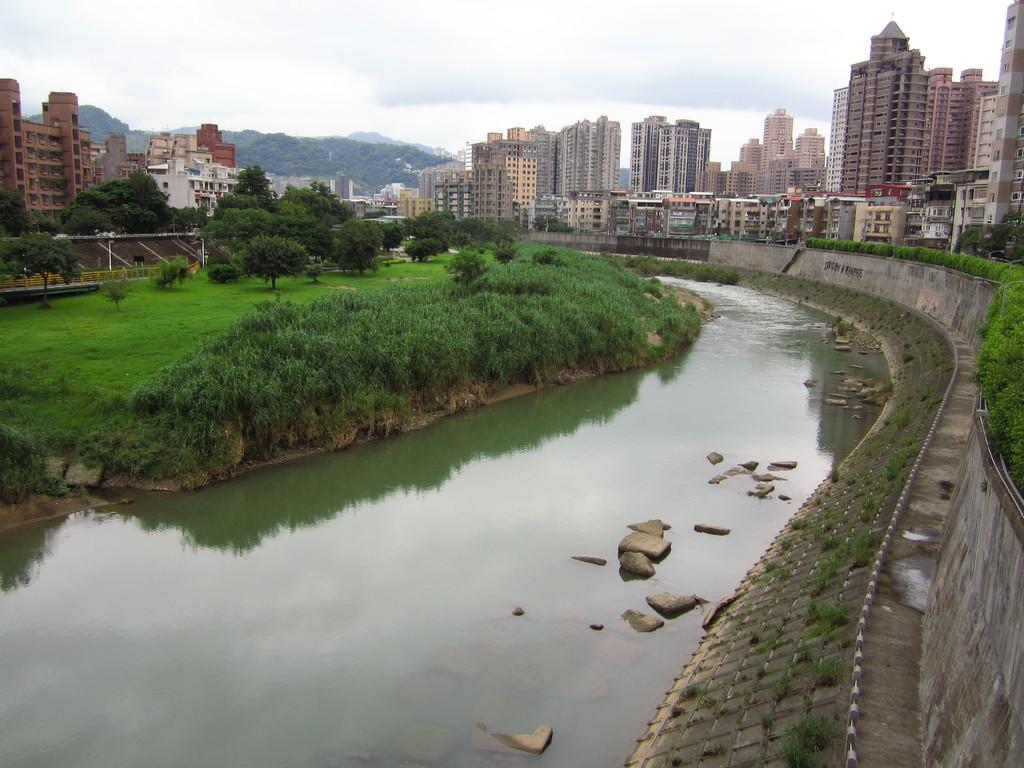Could you give a brief overview of what you see in this image? In this image there is a lake in the middle beside that there is grass and trees also there are so many buildings on the other side of lake. 